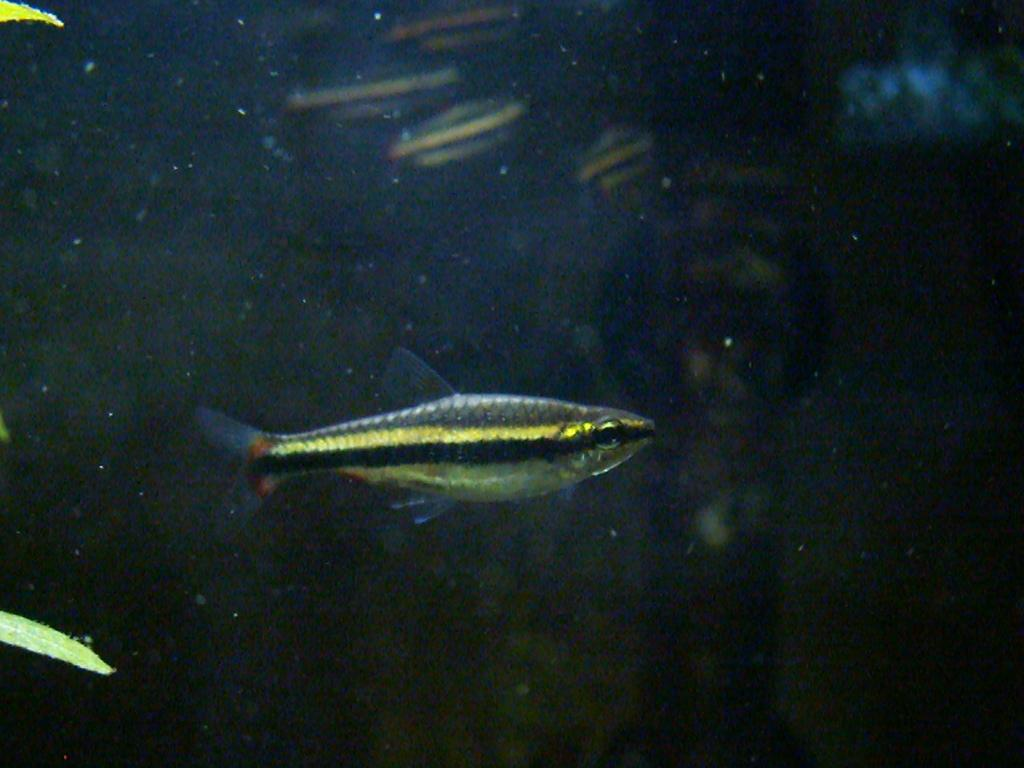Where was the image taken? The image is taken inside a fish tank. What can be seen swimming in the image? There are fishes in the image. What is the primary substance in the image? There is water in the image. What type of vegetation is present in the image? There are leaves on the left side of the image. How many jars can be seen in the image? There are no jars present in the image; it is taken inside a fish tank. Can you tell me the height of the man in the image? There is no man present in the image; it features fishes inside a fish tank. 